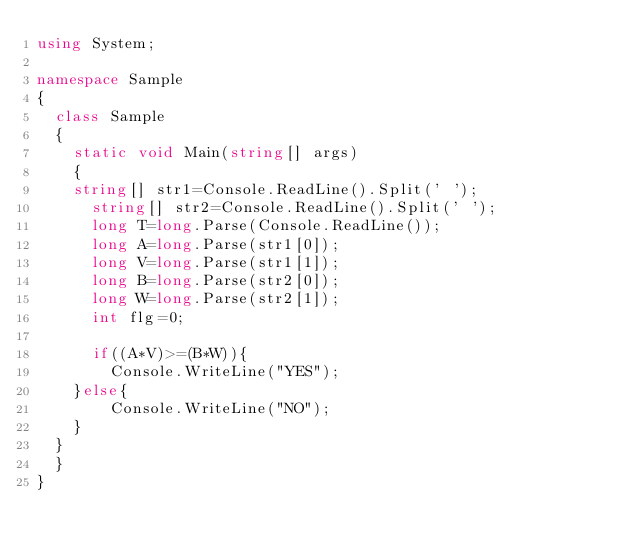<code> <loc_0><loc_0><loc_500><loc_500><_C#_>using System;
 
namespace Sample
{
  class Sample
  {
    static void Main(string[] args)
    {
    string[] str1=Console.ReadLine().Split(' ');
      string[] str2=Console.ReadLine().Split(' ');
      long T=long.Parse(Console.ReadLine());
      long A=long.Parse(str1[0]);
      long V=long.Parse(str1[1]);    
      long B=long.Parse(str2[0]); 
      long W=long.Parse(str2[1]); 
      int flg=0;

      if((A*V)>=(B*W)){
        Console.WriteLine("YES");
    }else{
        Console.WriteLine("NO");
    }
  }
  }
}</code> 